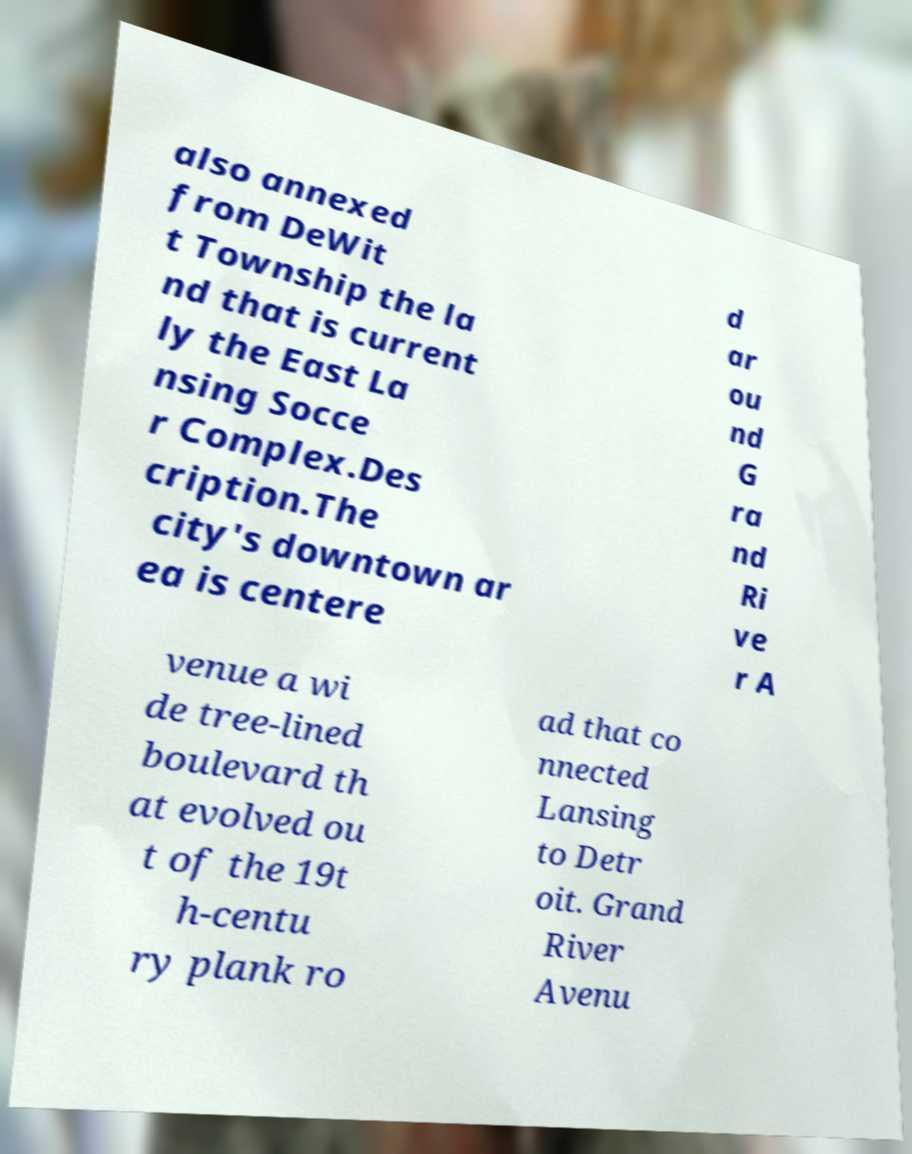For documentation purposes, I need the text within this image transcribed. Could you provide that? also annexed from DeWit t Township the la nd that is current ly the East La nsing Socce r Complex.Des cription.The city's downtown ar ea is centere d ar ou nd G ra nd Ri ve r A venue a wi de tree-lined boulevard th at evolved ou t of the 19t h-centu ry plank ro ad that co nnected Lansing to Detr oit. Grand River Avenu 